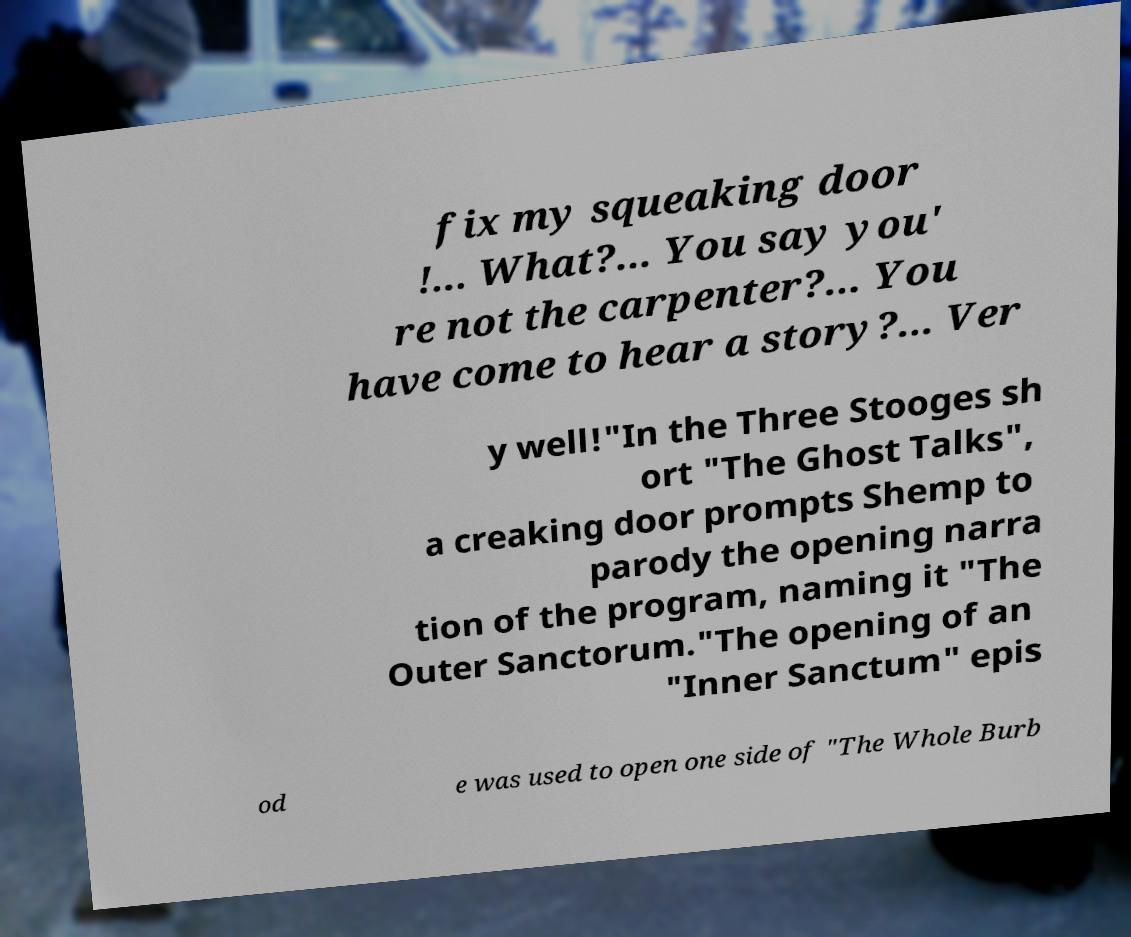What messages or text are displayed in this image? I need them in a readable, typed format. fix my squeaking door !... What?... You say you' re not the carpenter?... You have come to hear a story?... Ver y well!"In the Three Stooges sh ort "The Ghost Talks", a creaking door prompts Shemp to parody the opening narra tion of the program, naming it "The Outer Sanctorum."The opening of an "Inner Sanctum" epis od e was used to open one side of "The Whole Burb 